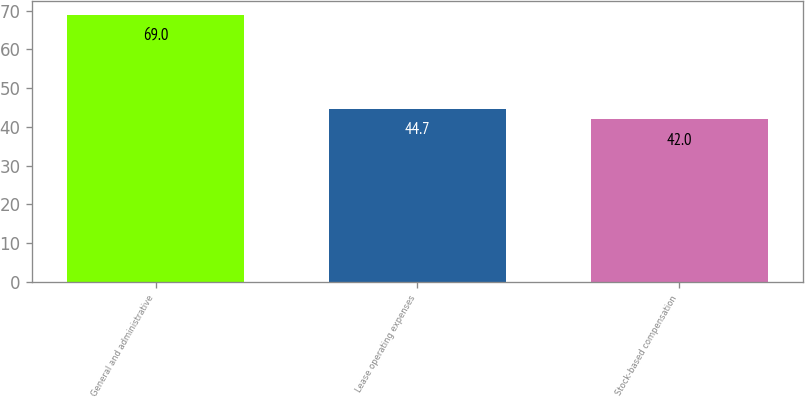Convert chart to OTSL. <chart><loc_0><loc_0><loc_500><loc_500><bar_chart><fcel>General and administrative<fcel>Lease operating expenses<fcel>Stock-based compensation<nl><fcel>69<fcel>44.7<fcel>42<nl></chart> 